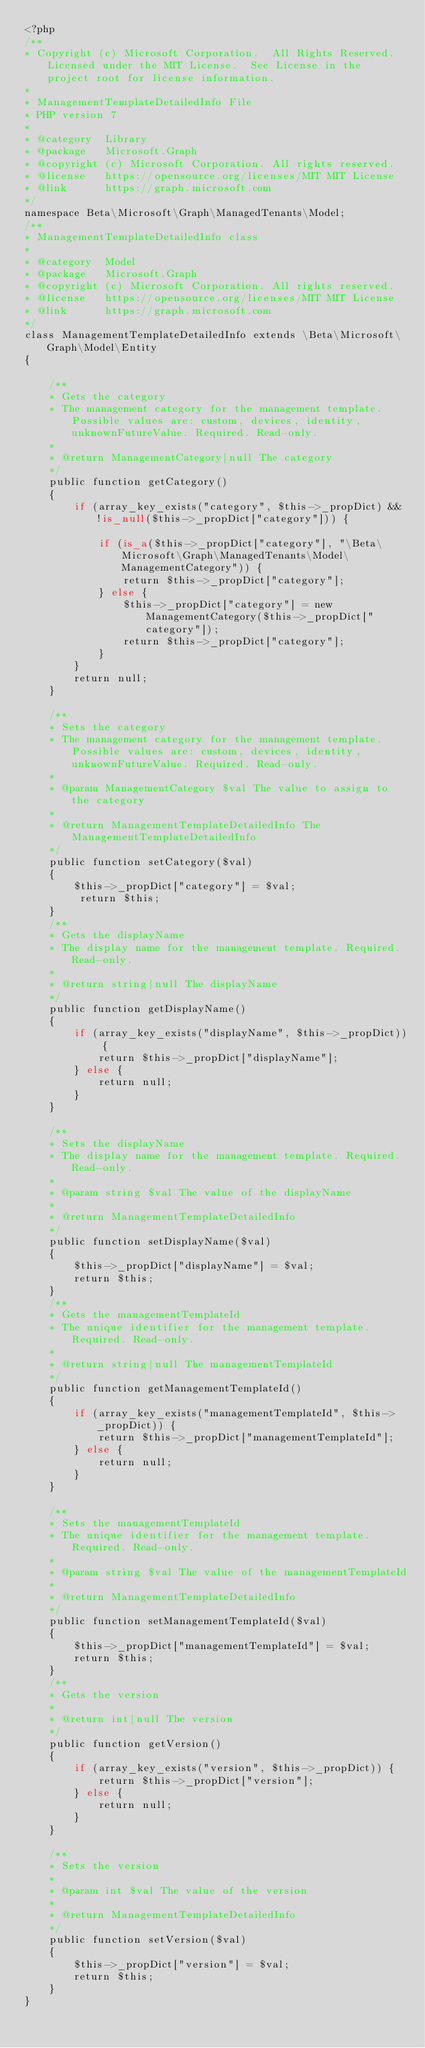Convert code to text. <code><loc_0><loc_0><loc_500><loc_500><_PHP_><?php
/**
* Copyright (c) Microsoft Corporation.  All Rights Reserved.  Licensed under the MIT License.  See License in the project root for license information.
* 
* ManagementTemplateDetailedInfo File
* PHP version 7
*
* @category  Library
* @package   Microsoft.Graph
* @copyright (c) Microsoft Corporation. All rights reserved.
* @license   https://opensource.org/licenses/MIT MIT License
* @link      https://graph.microsoft.com
*/
namespace Beta\Microsoft\Graph\ManagedTenants\Model;
/**
* ManagementTemplateDetailedInfo class
*
* @category  Model
* @package   Microsoft.Graph
* @copyright (c) Microsoft Corporation. All rights reserved.
* @license   https://opensource.org/licenses/MIT MIT License
* @link      https://graph.microsoft.com
*/
class ManagementTemplateDetailedInfo extends \Beta\Microsoft\Graph\Model\Entity
{

    /**
    * Gets the category
    * The management category for the management template. Possible values are: custom, devices, identity, unknownFutureValue. Required. Read-only.
    *
    * @return ManagementCategory|null The category
    */
    public function getCategory()
    {
        if (array_key_exists("category", $this->_propDict) && !is_null($this->_propDict["category"])) {
     
            if (is_a($this->_propDict["category"], "\Beta\Microsoft\Graph\ManagedTenants\Model\ManagementCategory")) {
                return $this->_propDict["category"];
            } else {
                $this->_propDict["category"] = new ManagementCategory($this->_propDict["category"]);
                return $this->_propDict["category"];
            }
        }
        return null;
    }

    /**
    * Sets the category
    * The management category for the management template. Possible values are: custom, devices, identity, unknownFutureValue. Required. Read-only.
    *
    * @param ManagementCategory $val The value to assign to the category
    *
    * @return ManagementTemplateDetailedInfo The ManagementTemplateDetailedInfo
    */
    public function setCategory($val)
    {
        $this->_propDict["category"] = $val;
         return $this;
    }
    /**
    * Gets the displayName
    * The display name for the management template. Required. Read-only.
    *
    * @return string|null The displayName
    */
    public function getDisplayName()
    {
        if (array_key_exists("displayName", $this->_propDict)) {
            return $this->_propDict["displayName"];
        } else {
            return null;
        }
    }

    /**
    * Sets the displayName
    * The display name for the management template. Required. Read-only.
    *
    * @param string $val The value of the displayName
    *
    * @return ManagementTemplateDetailedInfo
    */
    public function setDisplayName($val)
    {
        $this->_propDict["displayName"] = $val;
        return $this;
    }
    /**
    * Gets the managementTemplateId
    * The unique identifier for the management template. Required. Read-only.
    *
    * @return string|null The managementTemplateId
    */
    public function getManagementTemplateId()
    {
        if (array_key_exists("managementTemplateId", $this->_propDict)) {
            return $this->_propDict["managementTemplateId"];
        } else {
            return null;
        }
    }

    /**
    * Sets the managementTemplateId
    * The unique identifier for the management template. Required. Read-only.
    *
    * @param string $val The value of the managementTemplateId
    *
    * @return ManagementTemplateDetailedInfo
    */
    public function setManagementTemplateId($val)
    {
        $this->_propDict["managementTemplateId"] = $val;
        return $this;
    }
    /**
    * Gets the version
    *
    * @return int|null The version
    */
    public function getVersion()
    {
        if (array_key_exists("version", $this->_propDict)) {
            return $this->_propDict["version"];
        } else {
            return null;
        }
    }

    /**
    * Sets the version
    *
    * @param int $val The value of the version
    *
    * @return ManagementTemplateDetailedInfo
    */
    public function setVersion($val)
    {
        $this->_propDict["version"] = $val;
        return $this;
    }
}
</code> 